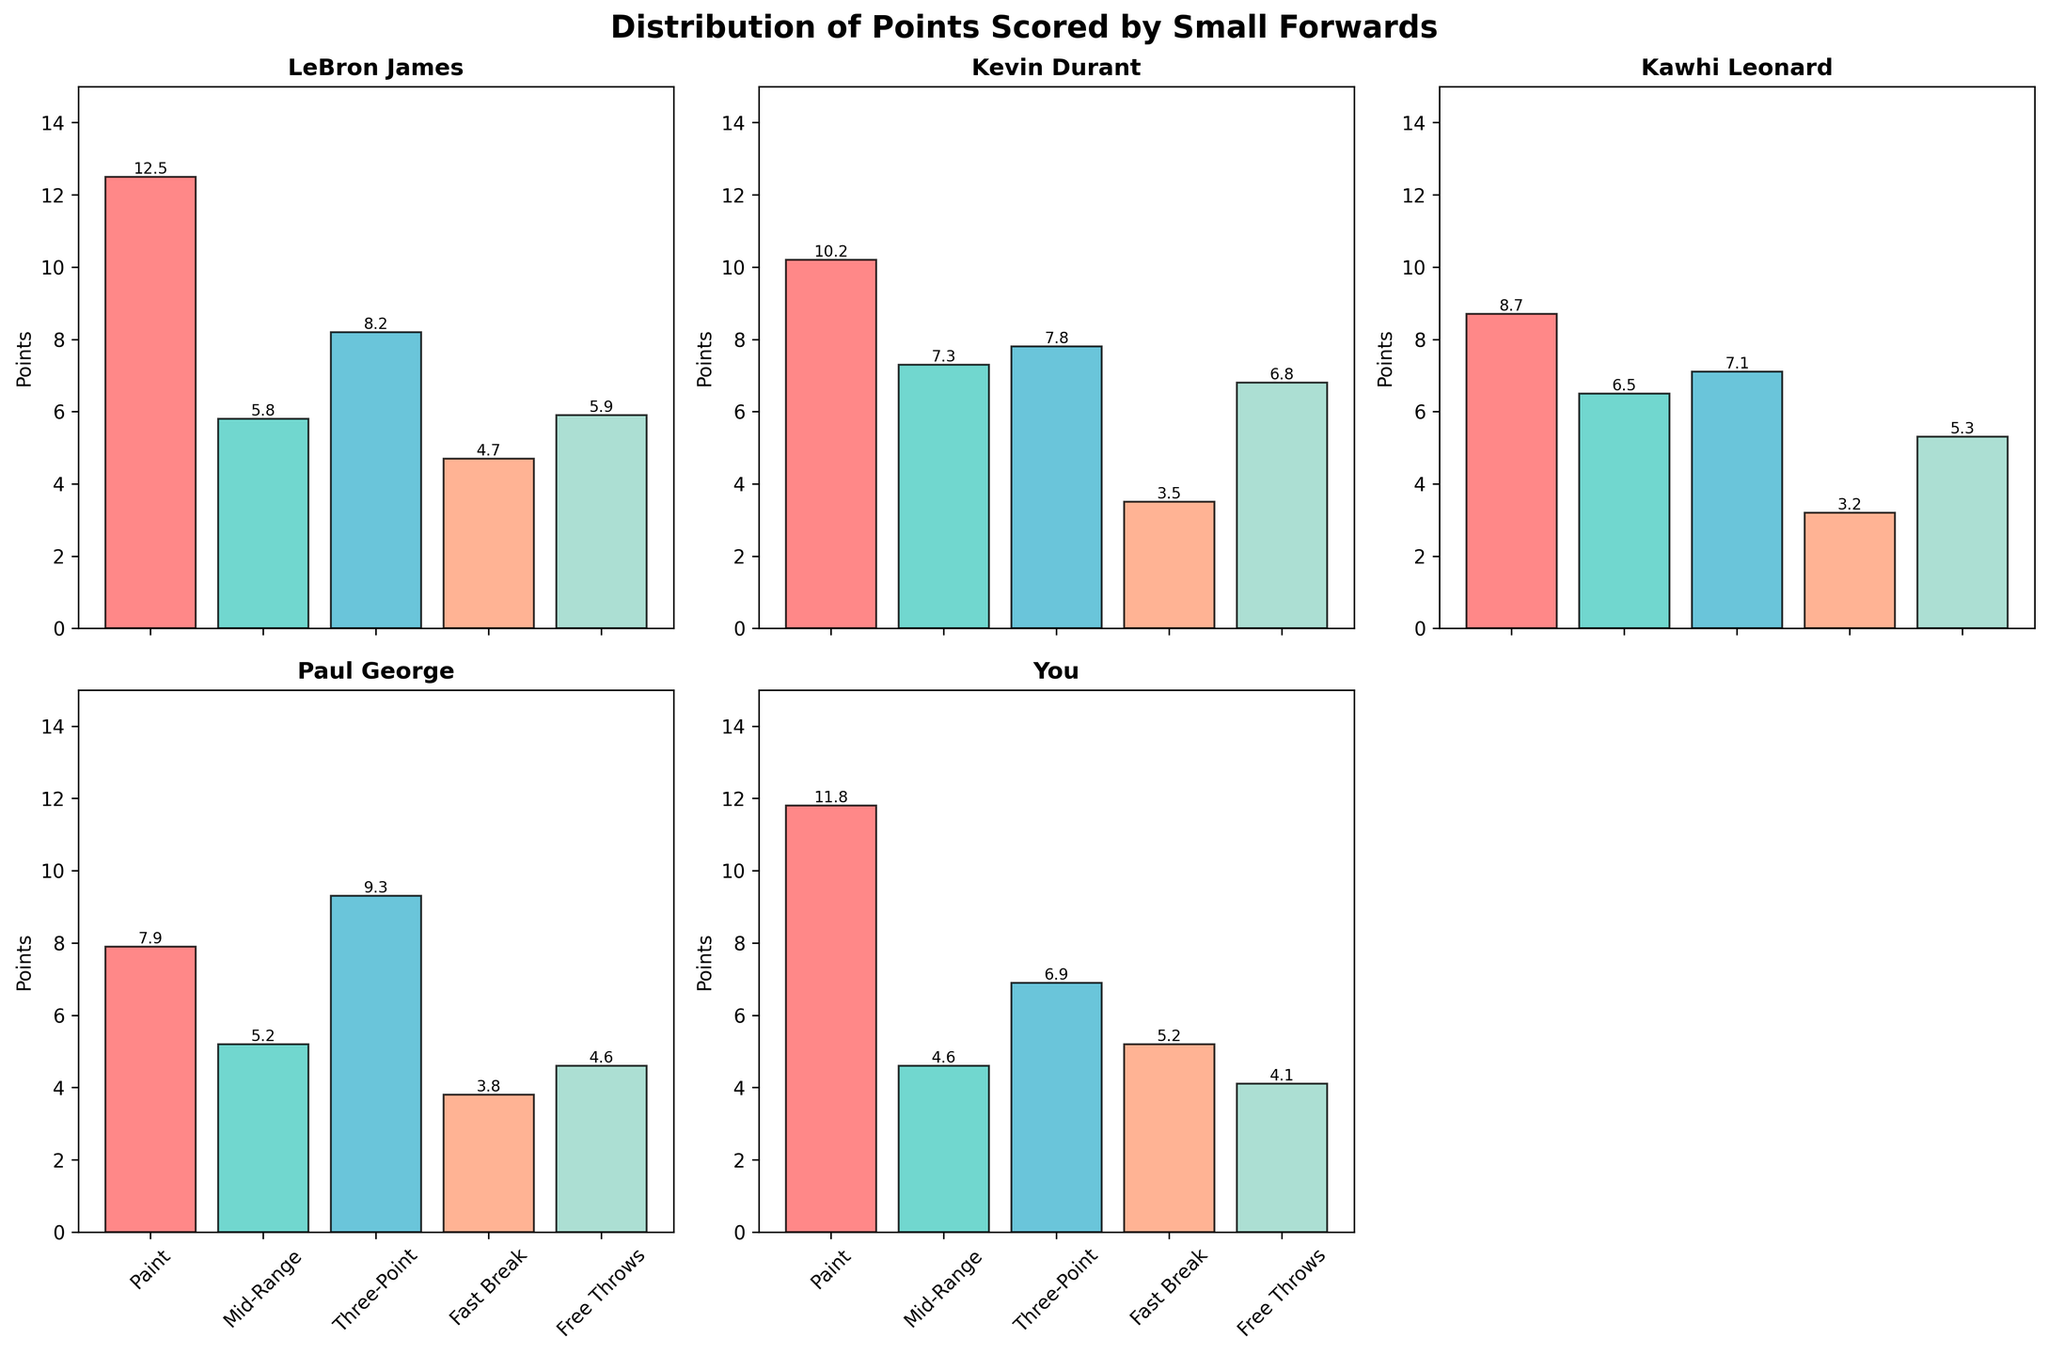What is the title of the figure? The title is located at the top center of the figure. It helps in understanding the overall subject of the plot.
Answer: Distribution of Points Scored by Small Forwards Which player scored the most points in the Paint zone? Compare the bar heights within the Paint zone across all players.
Answer: LeBron James Which shot zone has the most balanced points distribution among all players? Look for the shot zone where data points (bars) have similar heights across players.
Answer: Mid-Range Which player scored the least points in Free Throws? Find the lowest bar value in the Free Throws shot zone.
Answer: You What is the total number of points scored by Kawhi Leonard in all shot zones? Sum up the points from all shot zones for Kawhi Leonard.
Answer: 30.8 Who scored more points on Fast Breaks, Kevin Durant or Paul George? Compare the bar heights for Fast Breaks between Kevin Durant and Paul George.
Answer: You What is the combined points scored by LeBron James and Kevin Durant in the Three-Point and Mid-Range zones? Add points from the Three-Point and Mid-Range zones for both LeBron James and Kevin Durant.
Answer: 28.9 Which player has higher variability in points scored across different shot zones? Compare the variability (difference between highest and lowest values) of bar heights for each player.
Answer: LeBron James What is the difference in points scored in the Paint zone between the player with the highest and lowest scores? Subtract the lowest points in the Paint zone from the highest points.
Answer: 4.6 What is the median value of points scored by You in all shot zones? Arrange the points scored by You in ascending order and find the middle value.
Answer: 5.2 